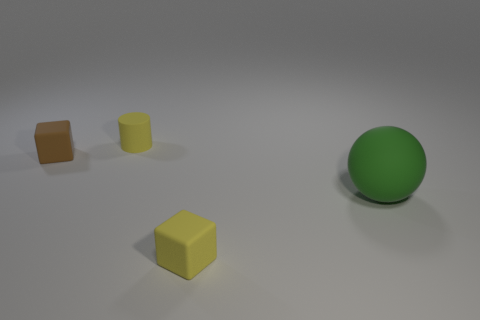Is the number of brown blocks less than the number of small purple blocks? From the image provided, there are no purple blocks present at all. Therefore, the number of brown blocks is not less than the number of small purple blocks, because there aren't any purple blocks to compare with. 